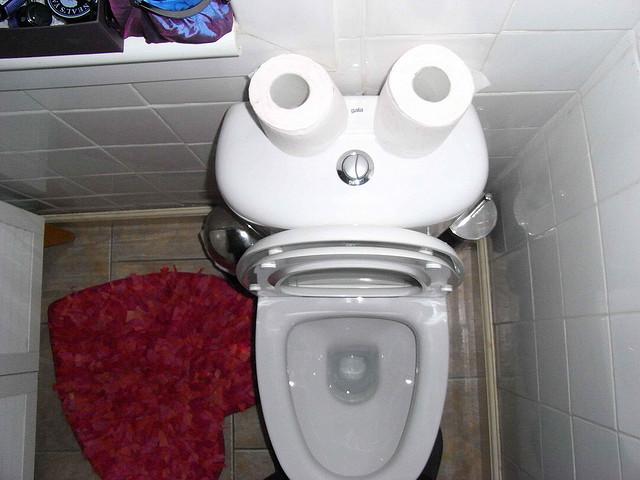What shape is the carpet?
Short answer required. Heart. How many toilet tissues are there?
Answer briefly. 2. Is the seat up?
Quick response, please. Yes. 